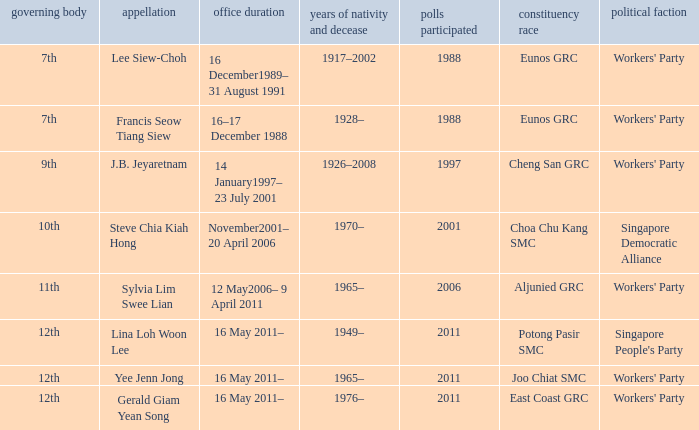What parliament's name is lina loh woon lee? 12th. 